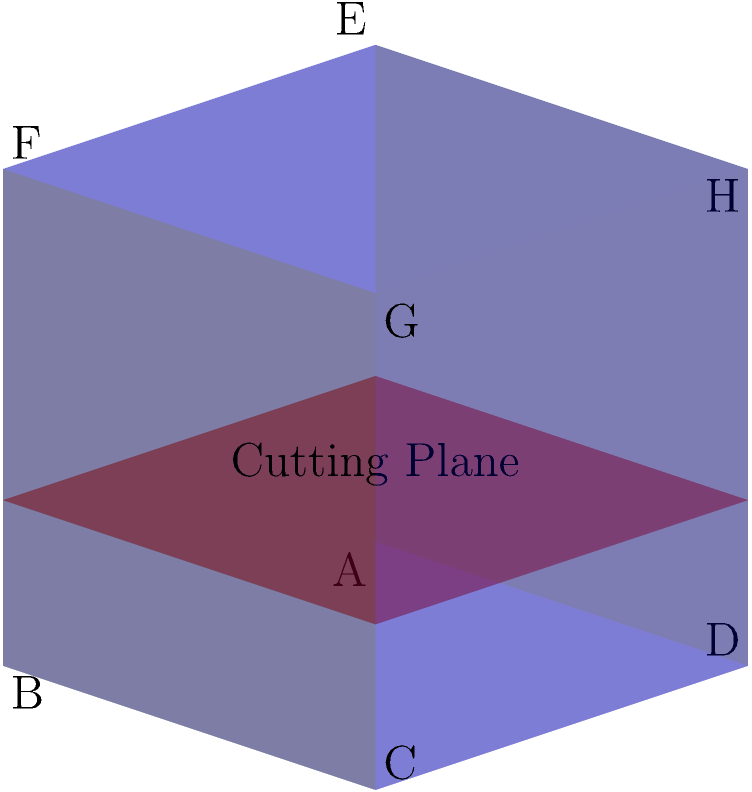A unit cube ABCDEFGH is intersected by a horizontal plane at a height of 1/3 from the base. What is the shape of the cross-section formed by this intersection? Additionally, if you were to calculate the area of this cross-section, what would be the result? To solve this problem, let's follow these steps:

1. Visualize the intersection:
   The horizontal plane cuts the cube parallel to its base at a height of 1/3.

2. Determine the shape of the cross-section:
   - Since the cutting plane is parallel to the base of the cube, the cross-section will have the same shape as the base.
   - The base of a cube is a square.
   - Therefore, the cross-section is also a square.

3. Calculate the area of the cross-section:
   - The cube is a unit cube, meaning its sides have a length of 1.
   - The cross-section is similar to the base but scaled down.
   - To find the scaling factor, we need to consider the similar triangles formed by the cutting plane and the cube's side.
   - The ratio of the height of the cutting plane to the height of the cube is 1/3.
   - This means the side length of the cross-section square is also 1/3 of the cube's side length.
   - Side length of the cross-section = $1 \times \frac{1}{3} = \frac{1}{3}$
   - Area of a square = side length squared
   - Area of the cross-section = $(\frac{1}{3})^2 = \frac{1}{9}$

Therefore, the cross-section is a square with an area of $\frac{1}{9}$ square units.
Answer: Square with area $\frac{1}{9}$ square units 